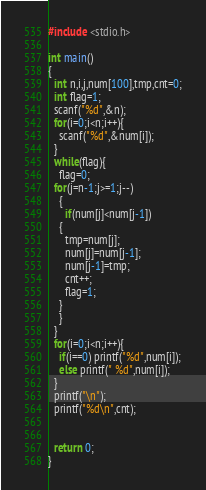Convert code to text. <code><loc_0><loc_0><loc_500><loc_500><_C_>#include <stdio.h>

int main()
{
  int n,i,j,num[100],tmp,cnt=0;
  int flag=1;
  scanf("%d",&n);
  for(i=0;i<n;i++){
    scanf("%d",&num[i]);
  }
  while(flag){
    flag=0;
  for(j=n-1;j>=1;j--)
    {
      if(num[j]<num[j-1])
	{
	  tmp=num[j];
	  num[j]=num[j-1];
	  num[j-1]=tmp;
	  cnt++;
	  flag=1;
	}
    }
  }
  for(i=0;i<n;i++){
    if(i==0) printf("%d",num[i]);
    else printf(" %d",num[i]);
  }
  printf("\n");
  printf("%d\n",cnt);
 

  return 0;
}

</code> 